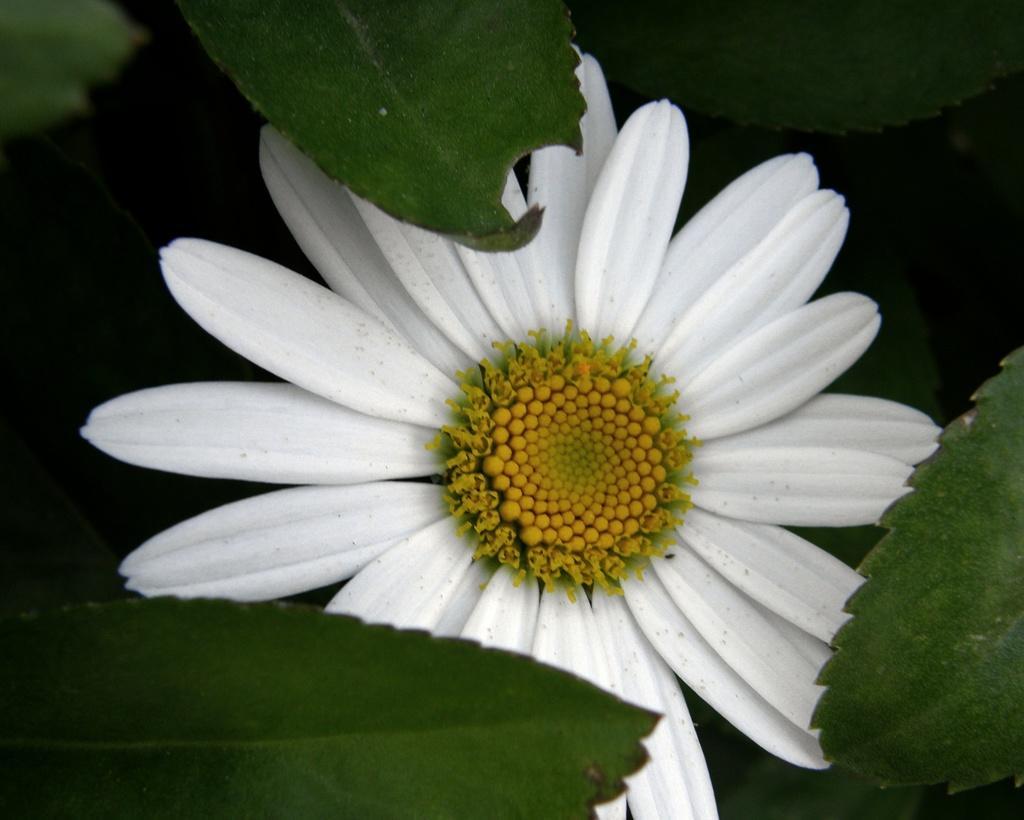Can you describe this image briefly? This is a plant, this is a white color flower. 